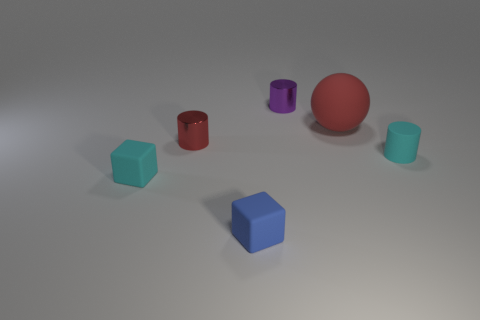Add 2 small cyan cylinders. How many objects exist? 8 Subtract all blocks. How many objects are left? 4 Subtract all purple shiny cylinders. Subtract all small red shiny objects. How many objects are left? 4 Add 1 rubber balls. How many rubber balls are left? 2 Add 6 large blue matte blocks. How many large blue matte blocks exist? 6 Subtract 0 green blocks. How many objects are left? 6 